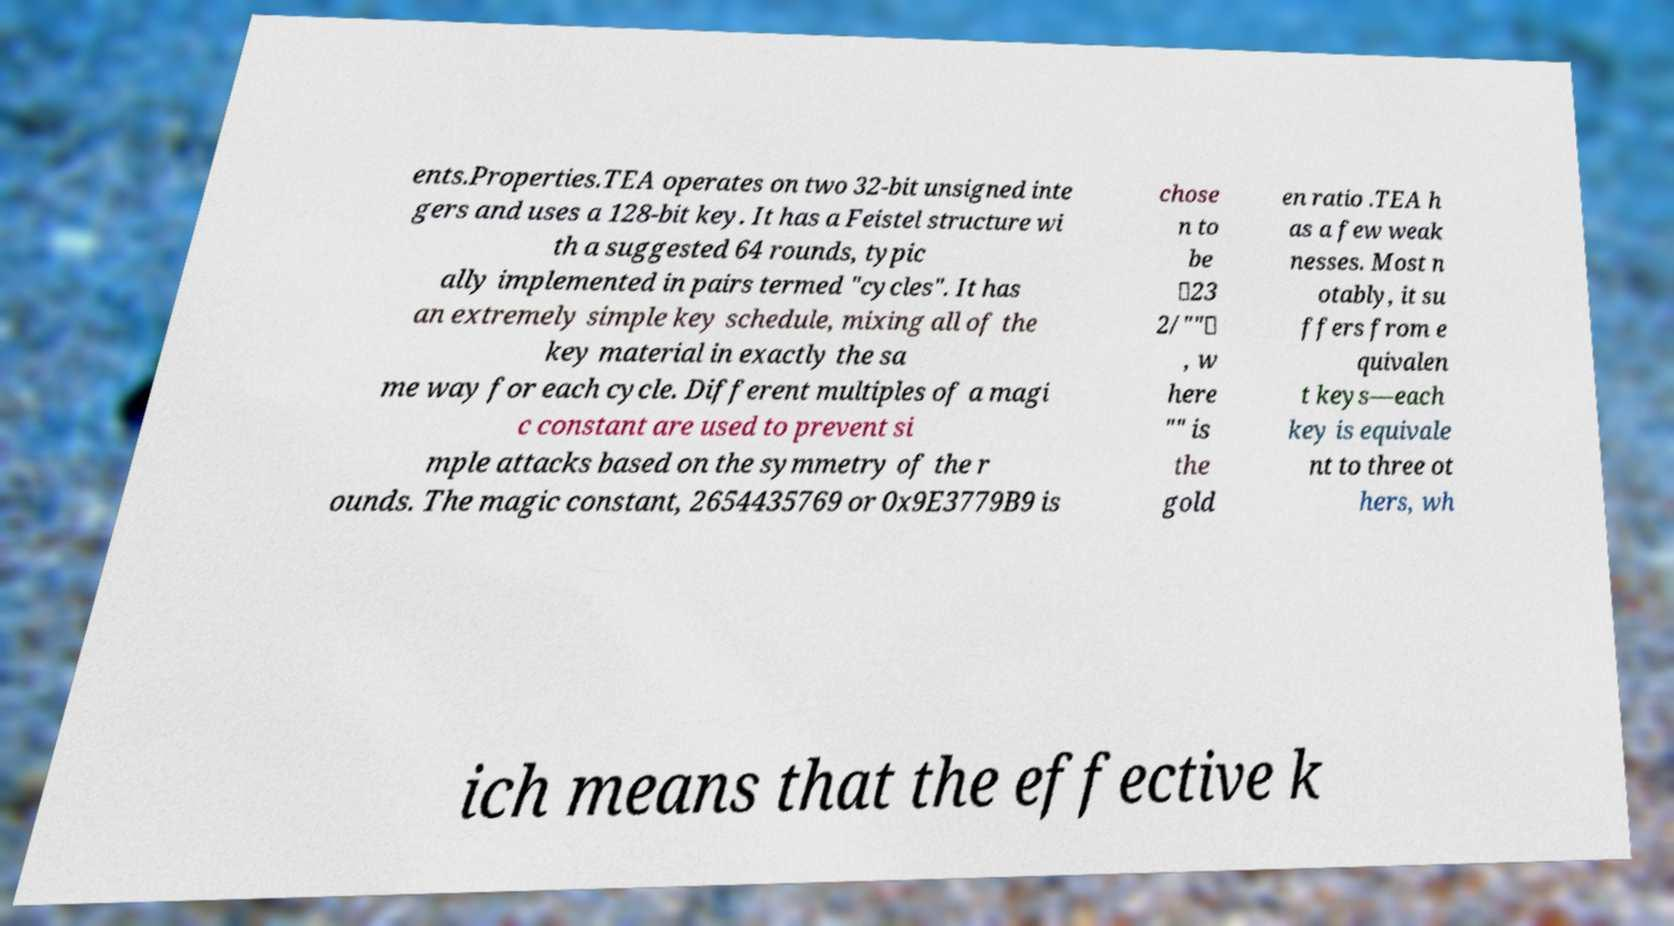I need the written content from this picture converted into text. Can you do that? ents.Properties.TEA operates on two 32-bit unsigned inte gers and uses a 128-bit key. It has a Feistel structure wi th a suggested 64 rounds, typic ally implemented in pairs termed "cycles". It has an extremely simple key schedule, mixing all of the key material in exactly the sa me way for each cycle. Different multiples of a magi c constant are used to prevent si mple attacks based on the symmetry of the r ounds. The magic constant, 2654435769 or 0x9E3779B9 is chose n to be ⌊23 2/""⌋ , w here "" is the gold en ratio .TEA h as a few weak nesses. Most n otably, it su ffers from e quivalen t keys—each key is equivale nt to three ot hers, wh ich means that the effective k 